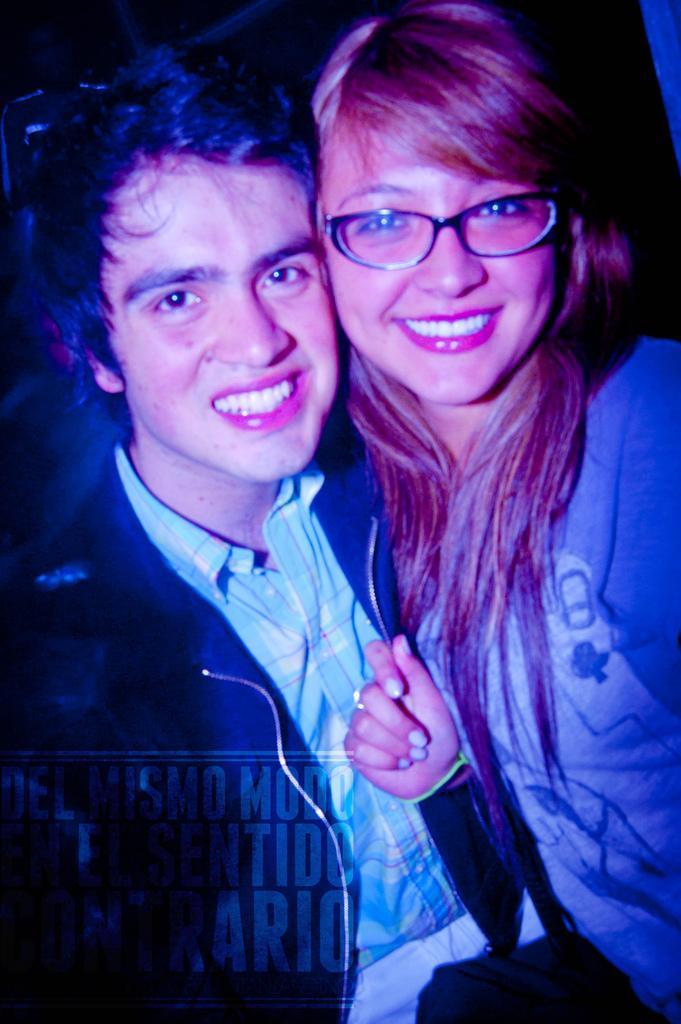Describe this image in one or two sentences. In this picture we can see two people, they are smiling, here we can see some text and in the background we can see it is dark. 